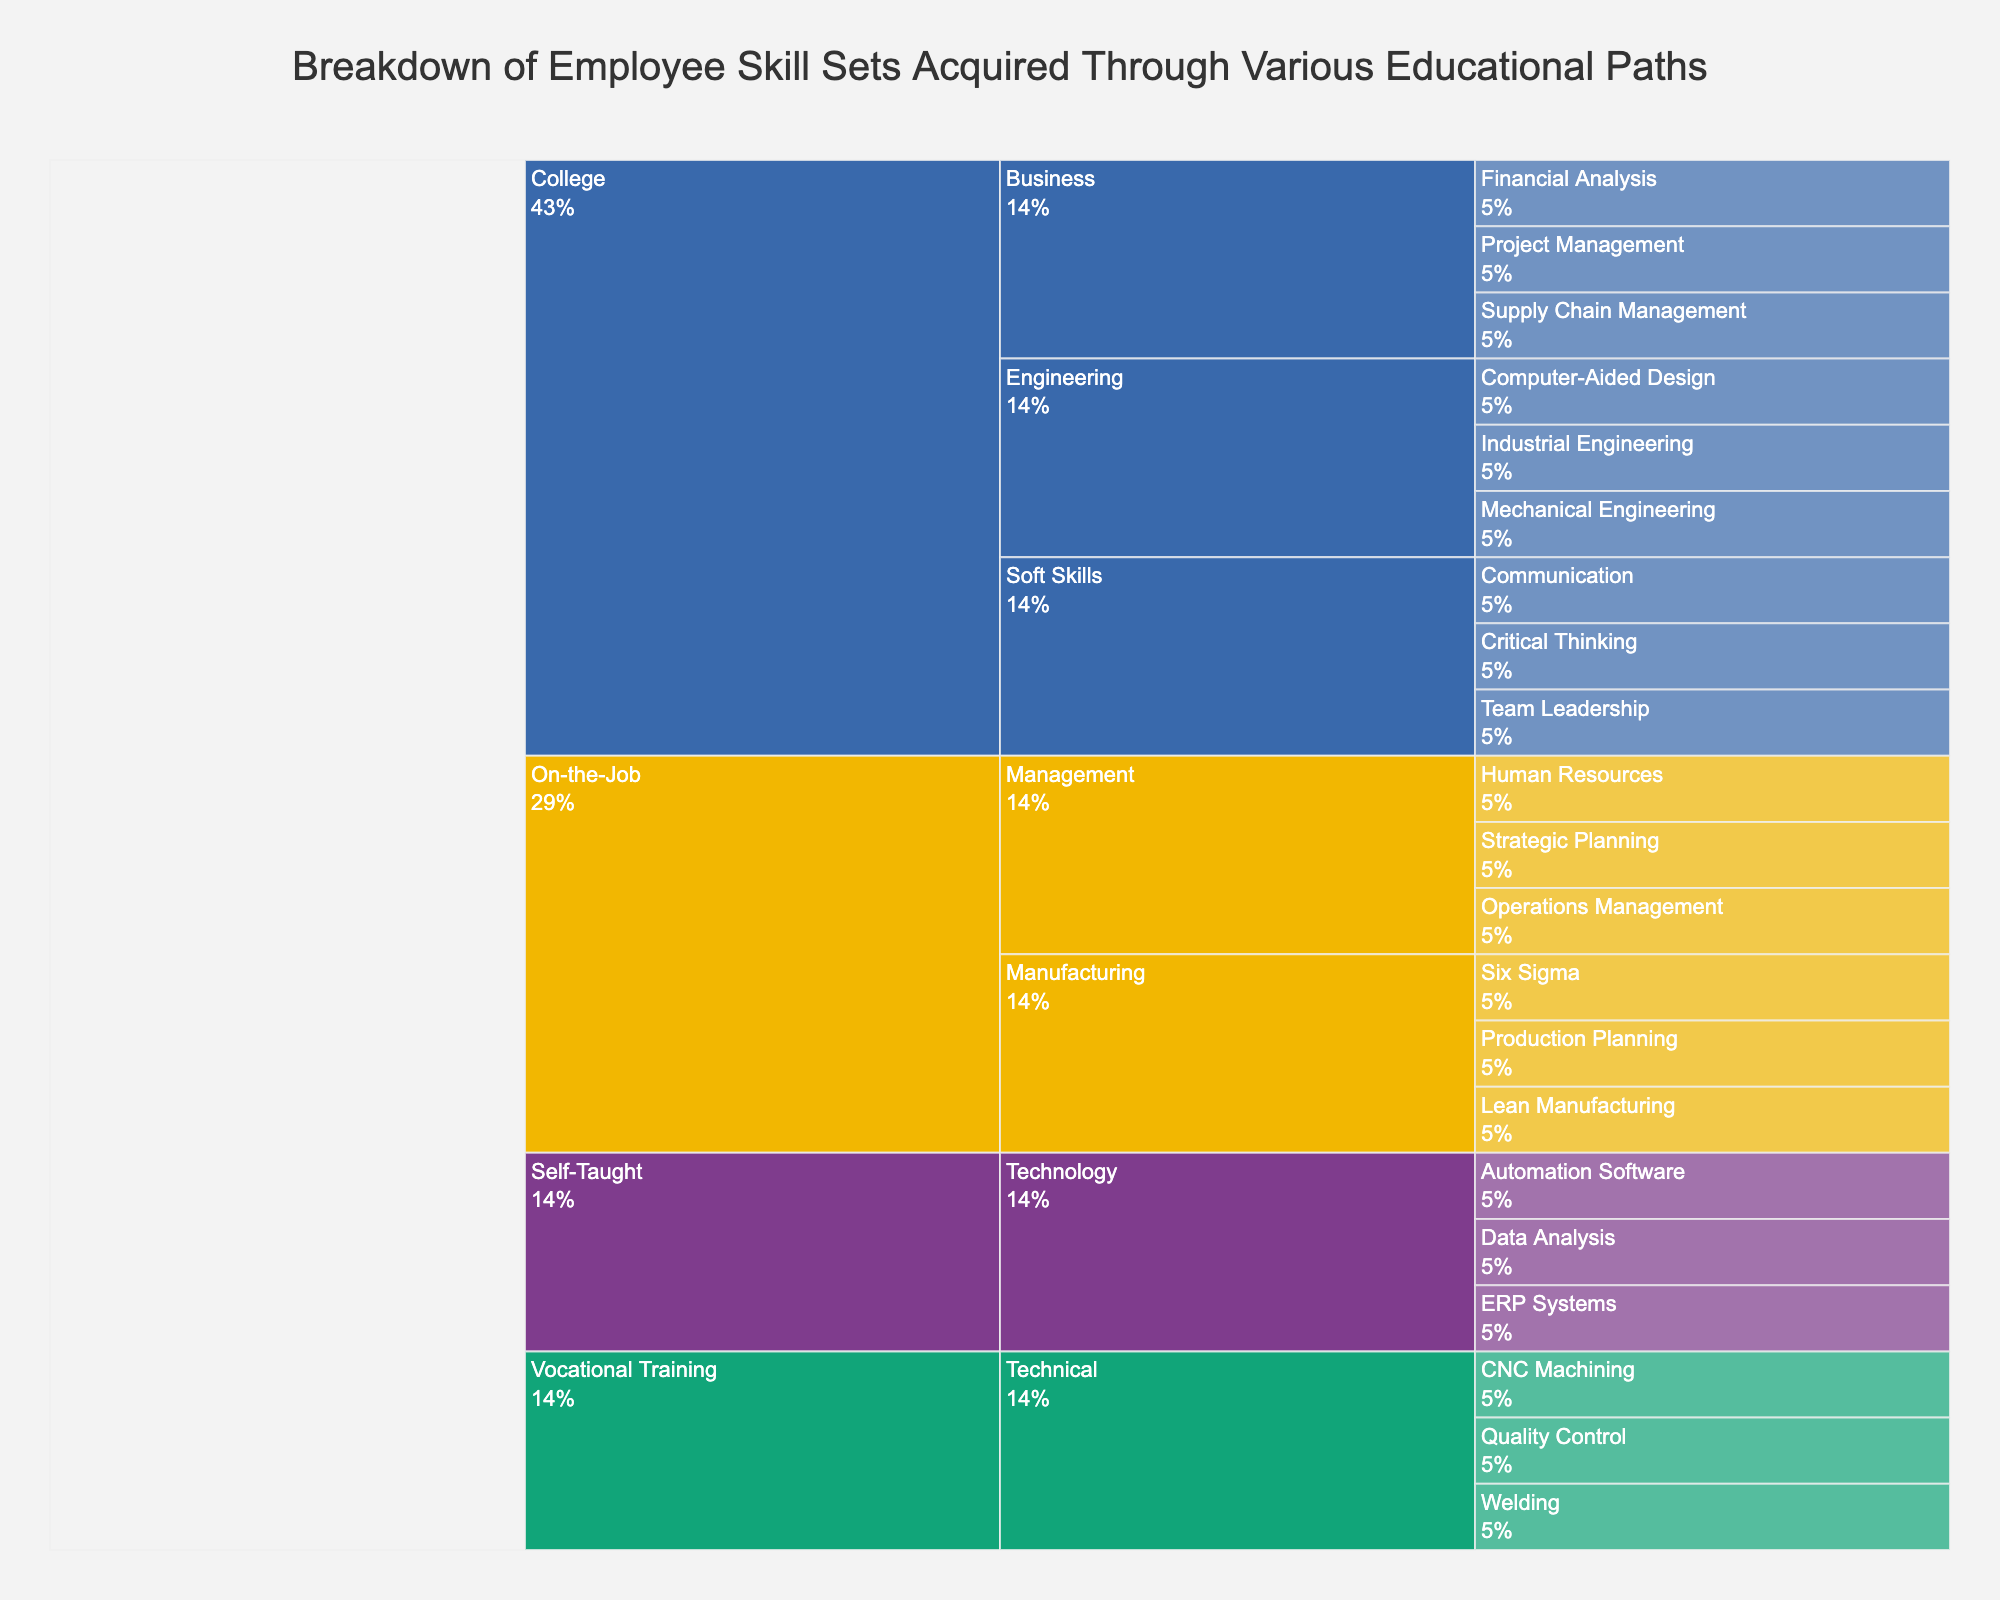Which skill source has the most categories? In the icicle chart, individual skill sources expand into their respective categories. Visually tracing each major branch, it is clear that the "College" branch splits into the most categories, which are Engineering, Business, and Soft Skills.
Answer: College What percentage of skills come from On-the-Job training in Manufacturing? Locate the "On-the-Job" skill source and identify the "Manufacturing" category under it. The icicle chart displays each subdivision's percentage. Sum these percentages to find the total contribution from "On-the-Job" training in Manufacturing.
Answer: 3 Which category under the College skill source has the least specific skills? From the chart, observe the subdivisions under "College." Compare the branch lengths for Engineering, Business, and Soft Skills. Count specific skills within each category. Critical Thinking, Team Leadership, and Communication are listed under Soft Skills, indicating Soft Skills has the least specific skills.
Answer: Soft Skills How do the number of skills in Technology from Self-Taught compare to Technical skills from Vocational Training? Trace both Self-Taught and Vocational Training paths. Under Self-Taught, focus on Technology and count Data Analysis, ERP Systems, and Automation Software. Similarly, in Vocational Training's Technical category, count CNC Machining, Welding, and Quality Control. Both splits into the same number of skills making them equal.
Answer: Equal Which educational path contributes more skills: College or Vocational Training? Tally the total number of specific skills listed under both College and Vocational Training paths. College has Mechanical Engineering, Industrial Engineering, Computer-Aided Design, Supply Chain Management, Financial Analysis, Project Management, Critical Thinking, Team Leadership, and Communication. Vocational Training includes CNC Machining, Welding, and Quality Control. College, with nine skills, surpasses Vocational Training’s three.
Answer: College How many management-related skills are gained through On-the-Job training? Focus on the "Management" category under On-the-Job in the icicle chart. Count the specific skills listed: Operations Management, Human Resources, and Strategic Planning. Totalling the specific skills results in three specific skills under Management.
Answer: 3 